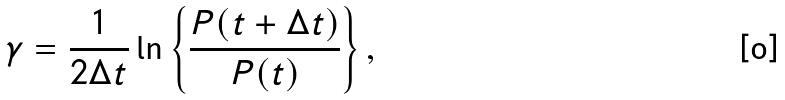<formula> <loc_0><loc_0><loc_500><loc_500>\gamma = \frac { 1 } { 2 \Delta t } \ln \left \{ \frac { P ( t + \Delta t ) } { P ( t ) } \right \} ,</formula> 